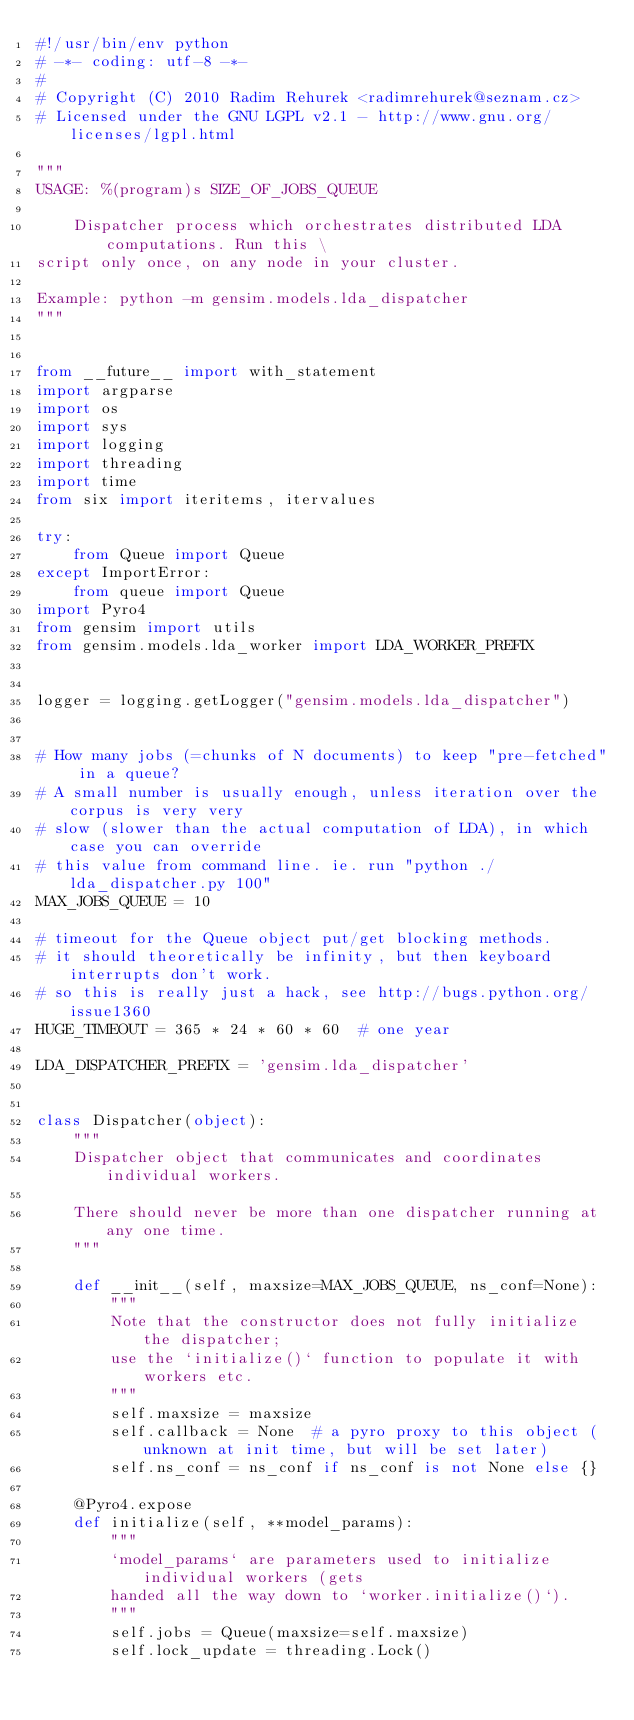Convert code to text. <code><loc_0><loc_0><loc_500><loc_500><_Python_>#!/usr/bin/env python
# -*- coding: utf-8 -*-
#
# Copyright (C) 2010 Radim Rehurek <radimrehurek@seznam.cz>
# Licensed under the GNU LGPL v2.1 - http://www.gnu.org/licenses/lgpl.html

"""
USAGE: %(program)s SIZE_OF_JOBS_QUEUE

    Dispatcher process which orchestrates distributed LDA computations. Run this \
script only once, on any node in your cluster.

Example: python -m gensim.models.lda_dispatcher
"""


from __future__ import with_statement
import argparse
import os
import sys
import logging
import threading
import time
from six import iteritems, itervalues

try:
    from Queue import Queue
except ImportError:
    from queue import Queue
import Pyro4
from gensim import utils
from gensim.models.lda_worker import LDA_WORKER_PREFIX


logger = logging.getLogger("gensim.models.lda_dispatcher")


# How many jobs (=chunks of N documents) to keep "pre-fetched" in a queue?
# A small number is usually enough, unless iteration over the corpus is very very
# slow (slower than the actual computation of LDA), in which case you can override
# this value from command line. ie. run "python ./lda_dispatcher.py 100"
MAX_JOBS_QUEUE = 10

# timeout for the Queue object put/get blocking methods.
# it should theoretically be infinity, but then keyboard interrupts don't work.
# so this is really just a hack, see http://bugs.python.org/issue1360
HUGE_TIMEOUT = 365 * 24 * 60 * 60  # one year

LDA_DISPATCHER_PREFIX = 'gensim.lda_dispatcher'


class Dispatcher(object):
    """
    Dispatcher object that communicates and coordinates individual workers.

    There should never be more than one dispatcher running at any one time.
    """

    def __init__(self, maxsize=MAX_JOBS_QUEUE, ns_conf=None):
        """
        Note that the constructor does not fully initialize the dispatcher;
        use the `initialize()` function to populate it with workers etc.
        """
        self.maxsize = maxsize
        self.callback = None  # a pyro proxy to this object (unknown at init time, but will be set later)
        self.ns_conf = ns_conf if ns_conf is not None else {}

    @Pyro4.expose
    def initialize(self, **model_params):
        """
        `model_params` are parameters used to initialize individual workers (gets
        handed all the way down to `worker.initialize()`).
        """
        self.jobs = Queue(maxsize=self.maxsize)
        self.lock_update = threading.Lock()</code> 